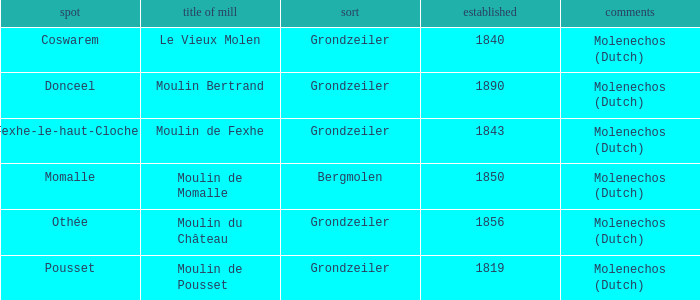Give me the full table as a dictionary. {'header': ['spot', 'title of mill', 'sort', 'established', 'comments'], 'rows': [['Coswarem', 'Le Vieux Molen', 'Grondzeiler', '1840', 'Molenechos (Dutch)'], ['Donceel', 'Moulin Bertrand', 'Grondzeiler', '1890', 'Molenechos (Dutch)'], ['Fexhe-le-haut-Clocher', 'Moulin de Fexhe', 'Grondzeiler', '1843', 'Molenechos (Dutch)'], ['Momalle', 'Moulin de Momalle', 'Bergmolen', '1850', 'Molenechos (Dutch)'], ['Othée', 'Moulin du Château', 'Grondzeiler', '1856', 'Molenechos (Dutch)'], ['Pousset', 'Moulin de Pousset', 'Grondzeiler', '1819', 'Molenechos (Dutch)']]} What is the Location of the Moulin Bertrand Mill? Donceel. 